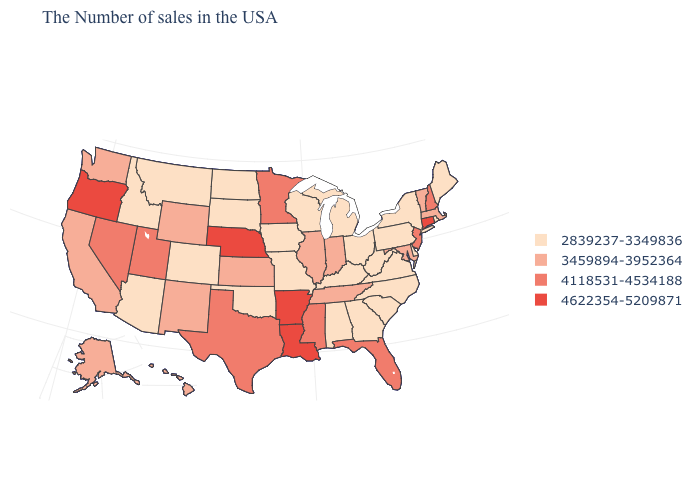Does the first symbol in the legend represent the smallest category?
Quick response, please. Yes. What is the value of Virginia?
Short answer required. 2839237-3349836. Name the states that have a value in the range 3459894-3952364?
Quick response, please. Massachusetts, Vermont, Maryland, Indiana, Tennessee, Illinois, Kansas, Wyoming, New Mexico, California, Washington, Alaska, Hawaii. Does North Dakota have a higher value than Pennsylvania?
Write a very short answer. No. Does New Hampshire have the lowest value in the Northeast?
Keep it brief. No. Which states hav the highest value in the Northeast?
Be succinct. Connecticut. Which states have the highest value in the USA?
Concise answer only. Connecticut, Louisiana, Arkansas, Nebraska, Oregon. Which states have the lowest value in the USA?
Concise answer only. Maine, Rhode Island, New York, Delaware, Pennsylvania, Virginia, North Carolina, South Carolina, West Virginia, Ohio, Georgia, Michigan, Kentucky, Alabama, Wisconsin, Missouri, Iowa, Oklahoma, South Dakota, North Dakota, Colorado, Montana, Arizona, Idaho. Among the states that border Wisconsin , which have the lowest value?
Give a very brief answer. Michigan, Iowa. Name the states that have a value in the range 4118531-4534188?
Quick response, please. New Hampshire, New Jersey, Florida, Mississippi, Minnesota, Texas, Utah, Nevada. What is the value of North Dakota?
Be succinct. 2839237-3349836. Among the states that border Maine , which have the highest value?
Short answer required. New Hampshire. Which states hav the highest value in the MidWest?
Concise answer only. Nebraska. What is the value of Kansas?
Quick response, please. 3459894-3952364. Name the states that have a value in the range 3459894-3952364?
Give a very brief answer. Massachusetts, Vermont, Maryland, Indiana, Tennessee, Illinois, Kansas, Wyoming, New Mexico, California, Washington, Alaska, Hawaii. 